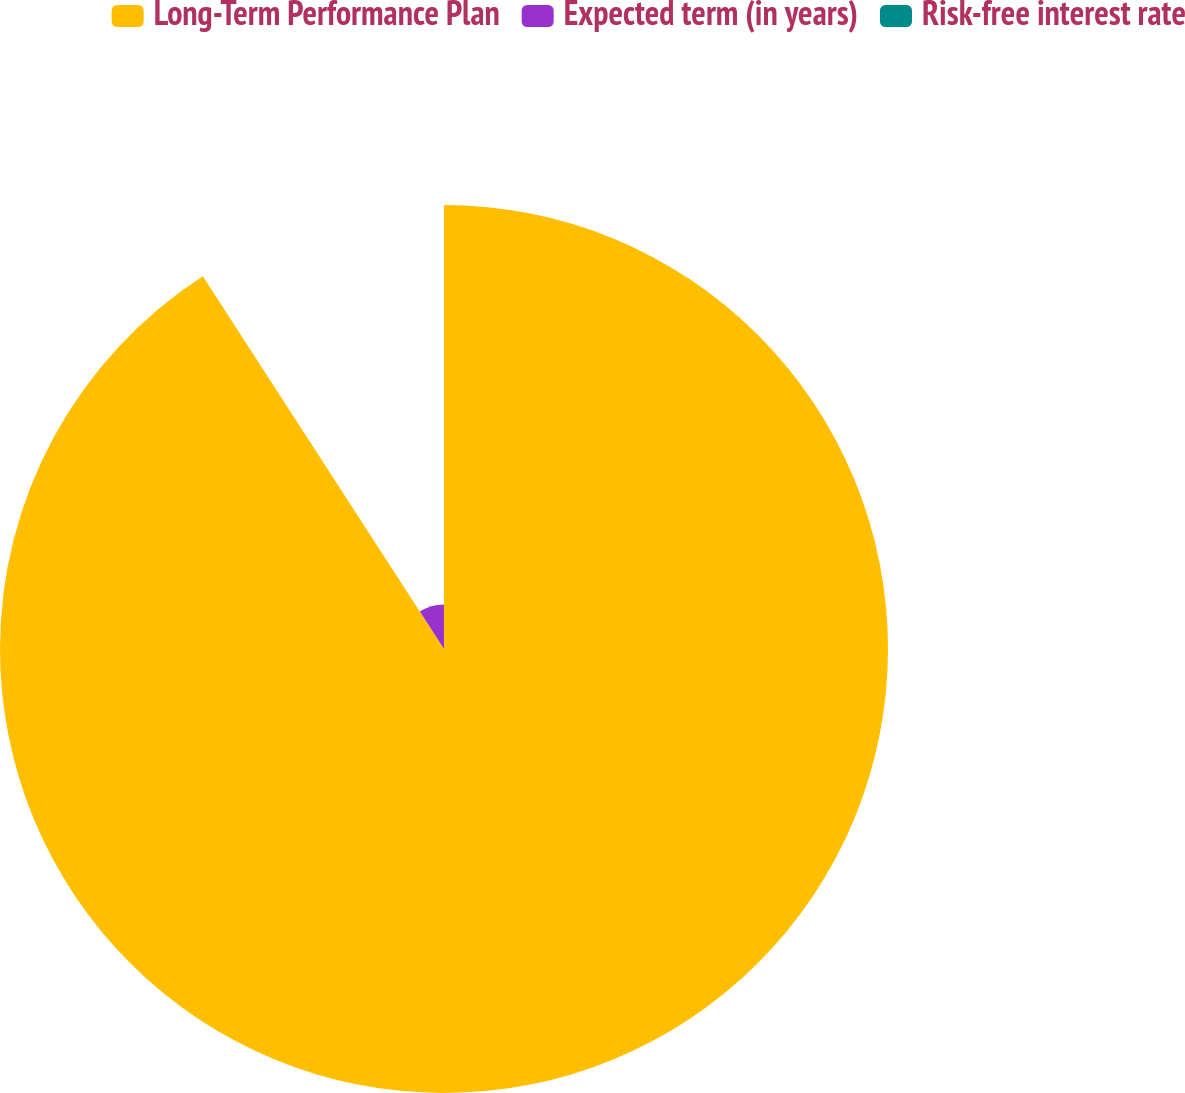Convert chart to OTSL. <chart><loc_0><loc_0><loc_500><loc_500><pie_chart><fcel>Long-Term Performance Plan<fcel>Expected term (in years)<fcel>Risk-free interest rate<nl><fcel>90.86%<fcel>9.11%<fcel>0.03%<nl></chart> 